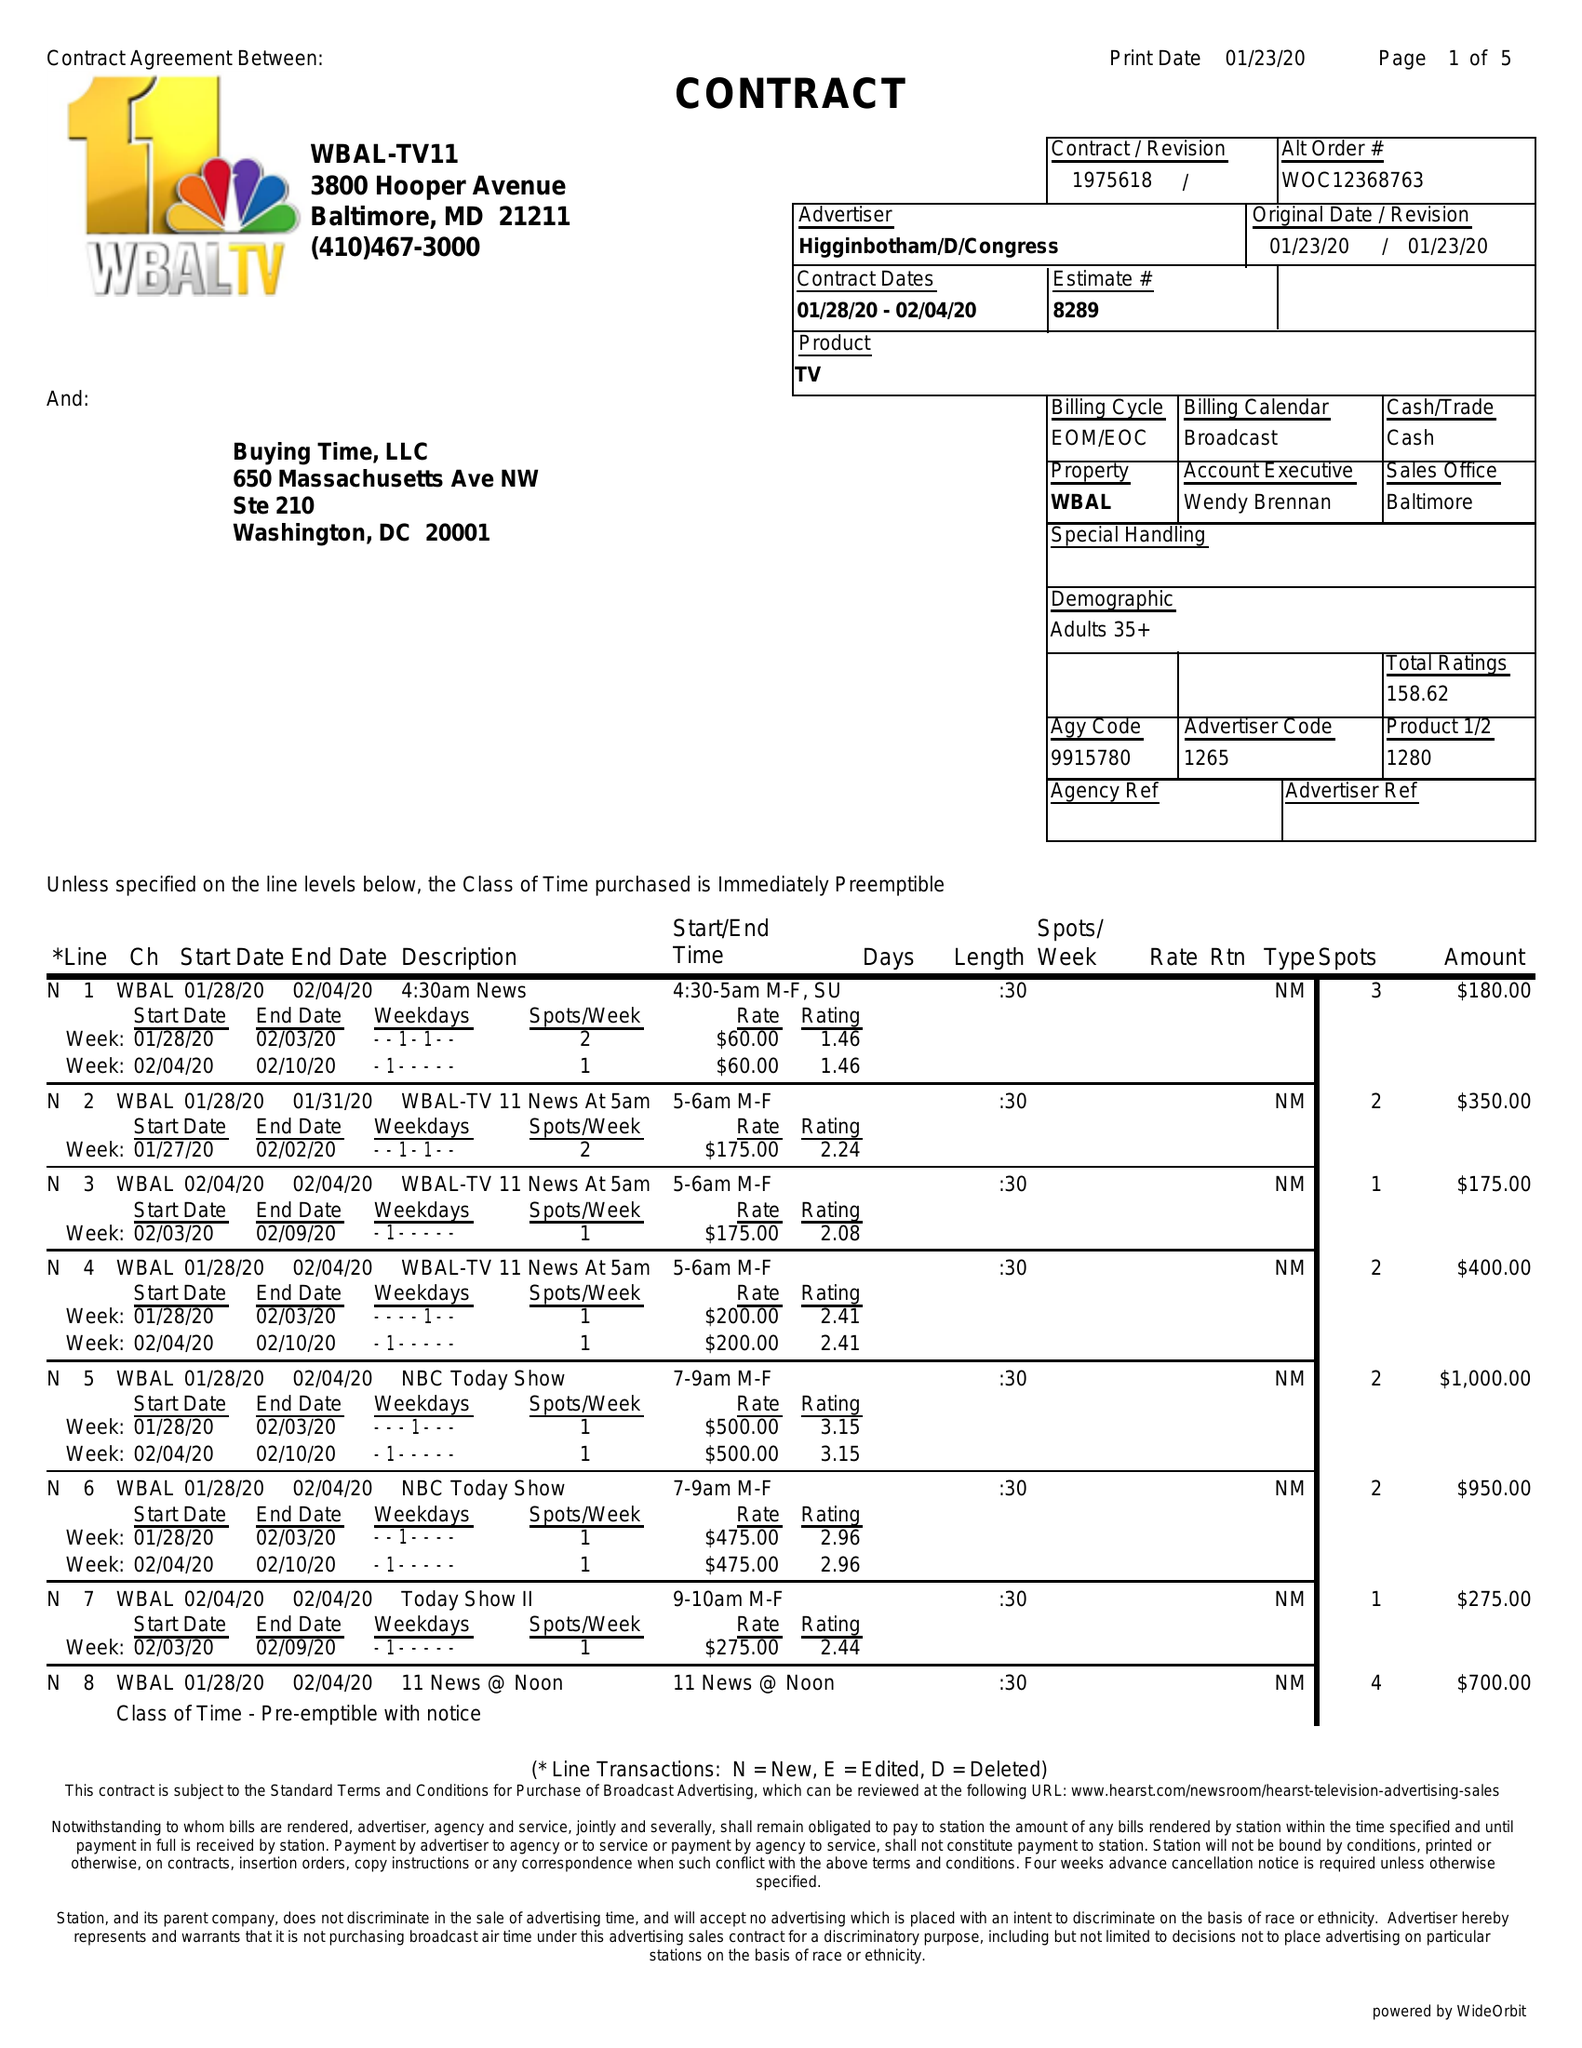What is the value for the gross_amount?
Answer the question using a single word or phrase. 20530.00 